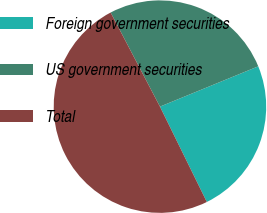Convert chart. <chart><loc_0><loc_0><loc_500><loc_500><pie_chart><fcel>Foreign government securities<fcel>US government securities<fcel>Total<nl><fcel>23.92%<fcel>26.49%<fcel>49.59%<nl></chart> 